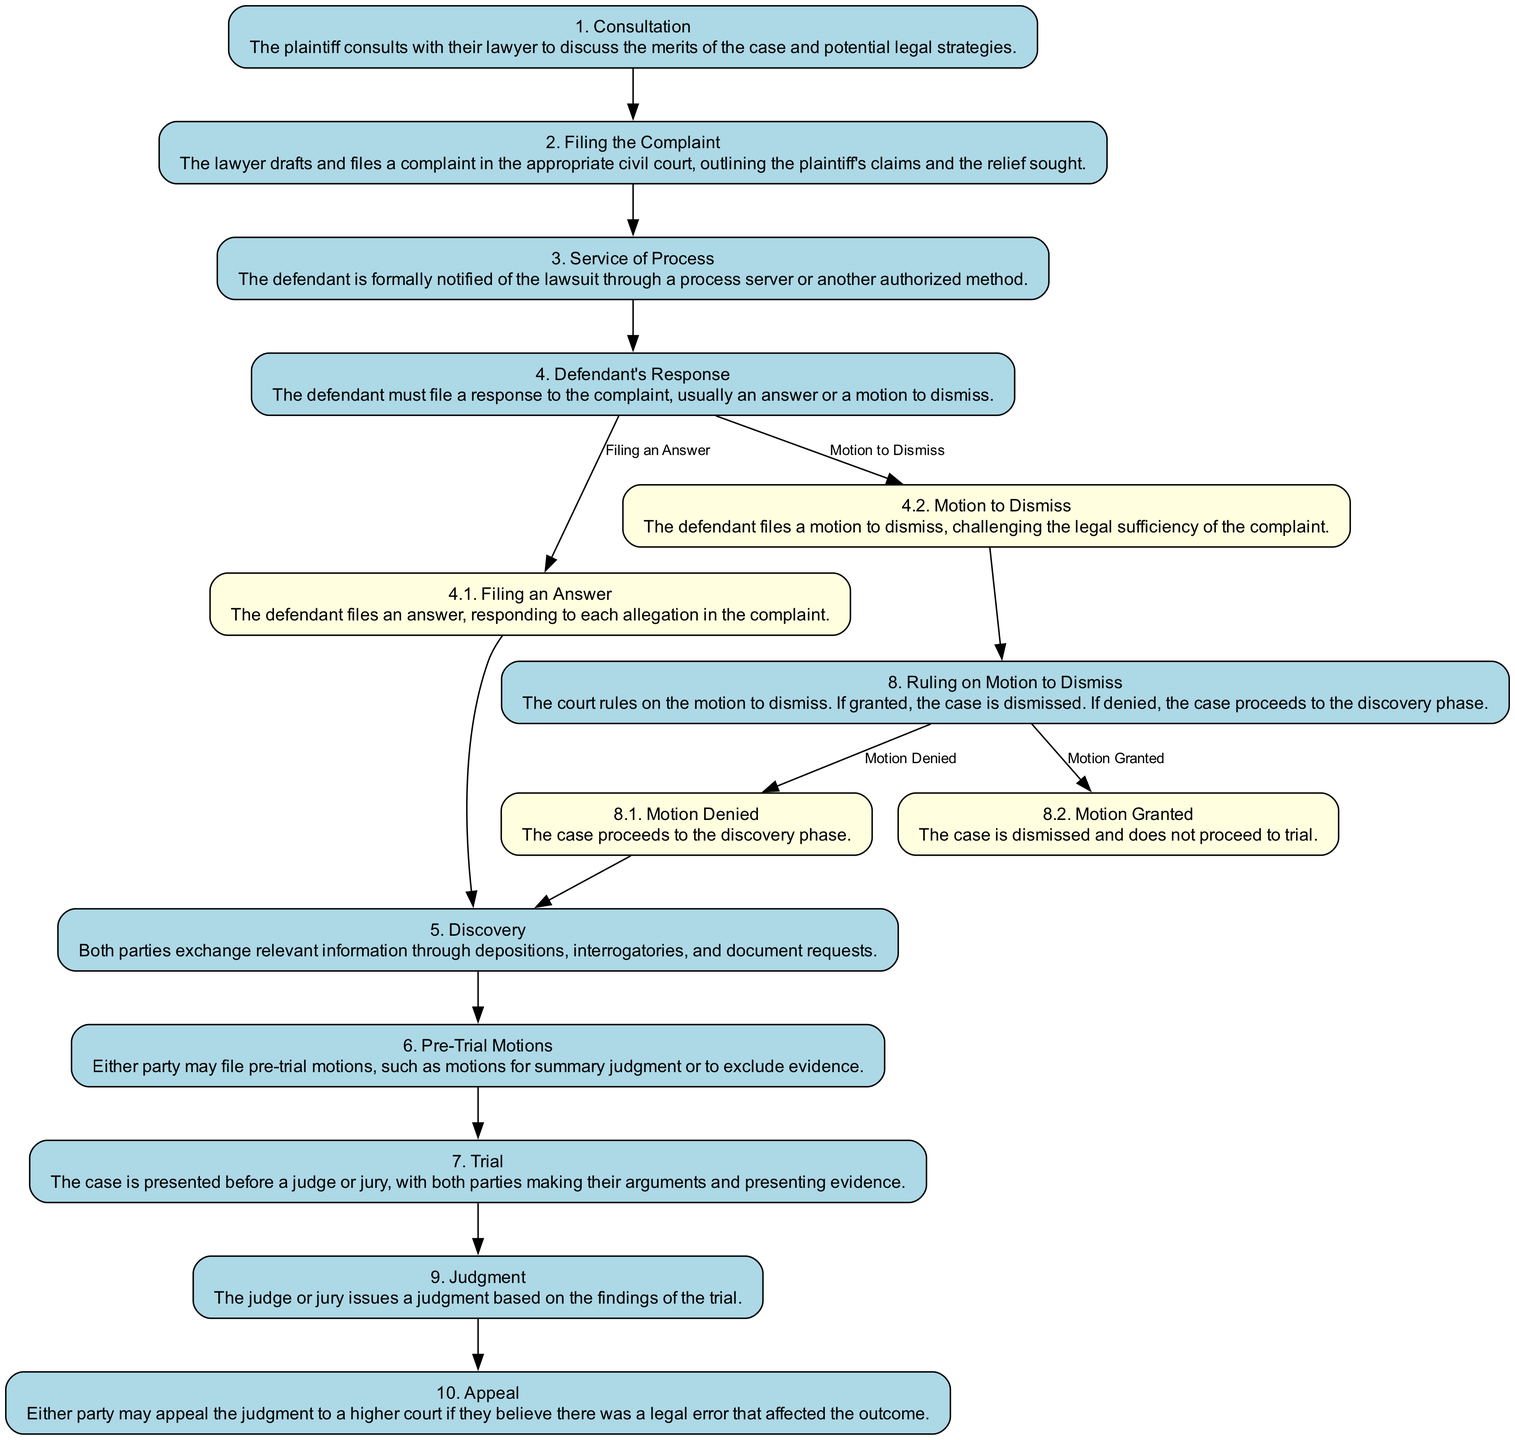What is the first step in the civil lawsuit process? The diagram shows that the first step is "Consultation," where the plaintiff consults with their lawyer.
Answer: Consultation What step follows "Filing the Complaint"? The diagram indicates that after "Filing the Complaint," the next step is "Service of Process."
Answer: Service of Process How many options does the "Defendant's Response" step have? The diagram lists two options under "Defendant's Response": "Filing an Answer" and "Motion to Dismiss," thus the count is two.
Answer: Two What happens if the "Motion to Dismiss" is denied? The diagram indicates that if the "Motion to Dismiss" is denied, the process proceeds to "Discovery," meaning both parties exchange relevant information.
Answer: Discovery What step concludes the civil lawsuit process? The diagram shows that the last step is "Appeal," where either party may appeal the judgment to a higher court if they believe there was a legal error.
Answer: Appeal What is the action taken in the "Trial" step? In the "Trial" step, the diagram states that the case is presented before a judge or jury, where both parties make arguments and present evidence.
Answer: Case presentation If the "Motion to Dismiss" is granted, what is the outcome? According to the diagram, if the "Motion to Dismiss" is granted, the case is dismissed and does not proceed to trial.
Answer: Case dismissed What step involves exchanging information through depositions? The “Discovery” step involves both parties exchanging relevant information through depositions, interrogatories, and document requests.
Answer: Discovery How many total steps are in the civil lawsuit process? By counting all the steps in the diagram, there are a total of ten steps in the civil lawsuit process.
Answer: Ten 